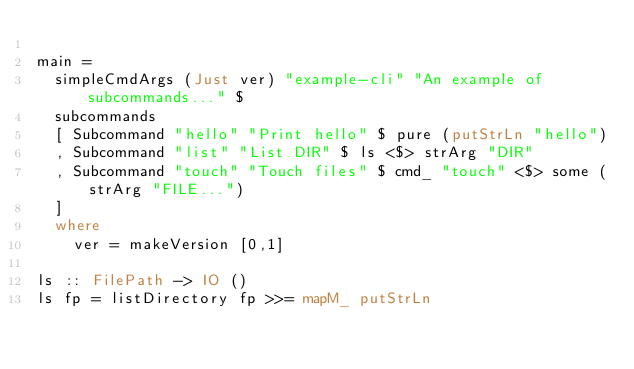<code> <loc_0><loc_0><loc_500><loc_500><_Haskell_>
main =
  simpleCmdArgs (Just ver) "example-cli" "An example of subcommands..." $
  subcommands
  [ Subcommand "hello" "Print hello" $ pure (putStrLn "hello")
  , Subcommand "list" "List DIR" $ ls <$> strArg "DIR"
  , Subcommand "touch" "Touch files" $ cmd_ "touch" <$> some (strArg "FILE...")
  ]
  where
    ver = makeVersion [0,1]

ls :: FilePath -> IO ()
ls fp = listDirectory fp >>= mapM_ putStrLn
</code> 